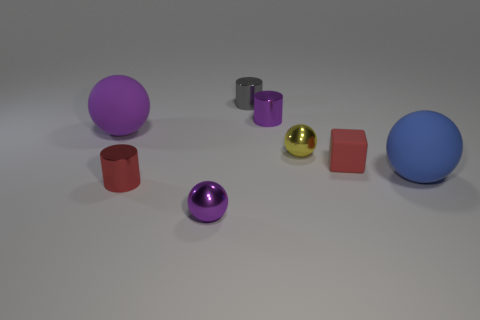Subtract all cyan spheres. Subtract all yellow blocks. How many spheres are left? 4 Add 2 big spheres. How many objects exist? 10 Subtract all blocks. How many objects are left? 7 Subtract 0 cyan balls. How many objects are left? 8 Subtract all gray shiny objects. Subtract all blue spheres. How many objects are left? 6 Add 2 tiny red metallic things. How many tiny red metallic things are left? 3 Add 7 small gray things. How many small gray things exist? 8 